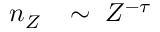<formula> <loc_0><loc_0><loc_500><loc_500>n _ { Z } \, \sim \, Z ^ { - \tau }</formula> 